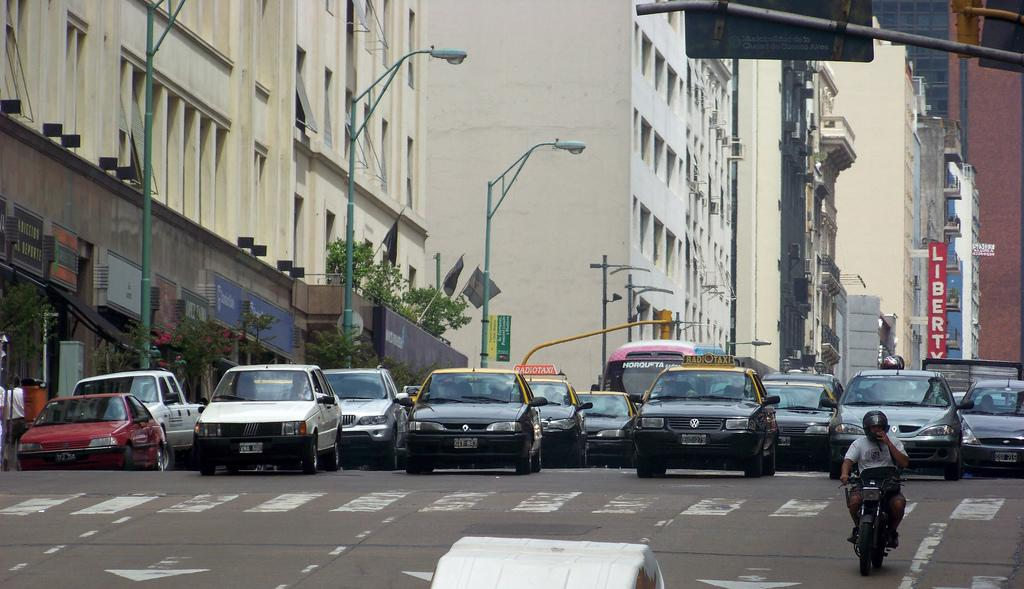What are the colors of the cars on the street, and what are the colors mentioned on the road signs? The cars on the street are red, black, and white. The road sign colors are red and white. Explain the context of the image in terms of its components such as vehicles, markings, and surrounding environment. The image context shows a busy city street with cars and a motorcyclist, traffic markings, and an urban backdrop with buildings, flags, and signs. What type of vehicle does the person wear a helmet on, and what color are the nearby cars' headlights? The person wearing a helmet is on a motorcycle, and the nearby cars' headlights are white. Identify the type of reasoning required to solve the complex reasoning task in the image. Spatial, temporal, and contextual reasoning is needed to understand the relationships between the different objects, activities, and their location in the image. Identify the objects found in the left-top corner of the image. In the left-top corner of the image, there is a row of buildings and a green tree with red flowers. Analyze the image and mention the actions of the people in it. A person is riding a motorcycle, while another person is wearing a helmet, and one more is wearing a white shirt. Describe the street in the image, including its markings and objects found on it. The street has white lines and arrows painted on it, several cars, a person on a motorbike, a street light on a green pole, and a red and white sign on a building. What is the sentiment of the image settings, according to the objects and activities depicted? The image sentiment reflects a bustling urban environment with people and vehicles moving about in their daily activities. Is there anything unusual in the image that could indicate an anomaly? There is no apparent anomaly in the image. All objects and activities appear to be normal for a street scene. What features of the buildings in the image should be extracted for the image segmentation task? Flags, signs, colors, size, and the number of floors in the buildings are important features for segmentation. 